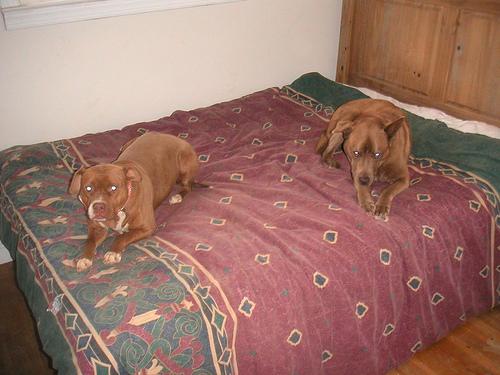Are the dogs sleeping?
Answer briefly. No. Do the dogs have glowing eyes?
Write a very short answer. Yes. Are the dogs being hostile?
Give a very brief answer. No. 